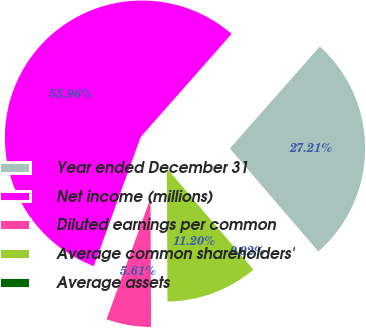Convert chart. <chart><loc_0><loc_0><loc_500><loc_500><pie_chart><fcel>Year ended December 31<fcel>Net income (millions)<fcel>Diluted earnings per common<fcel>Average common shareholders'<fcel>Average assets<nl><fcel>27.21%<fcel>55.96%<fcel>5.61%<fcel>11.2%<fcel>0.02%<nl></chart> 